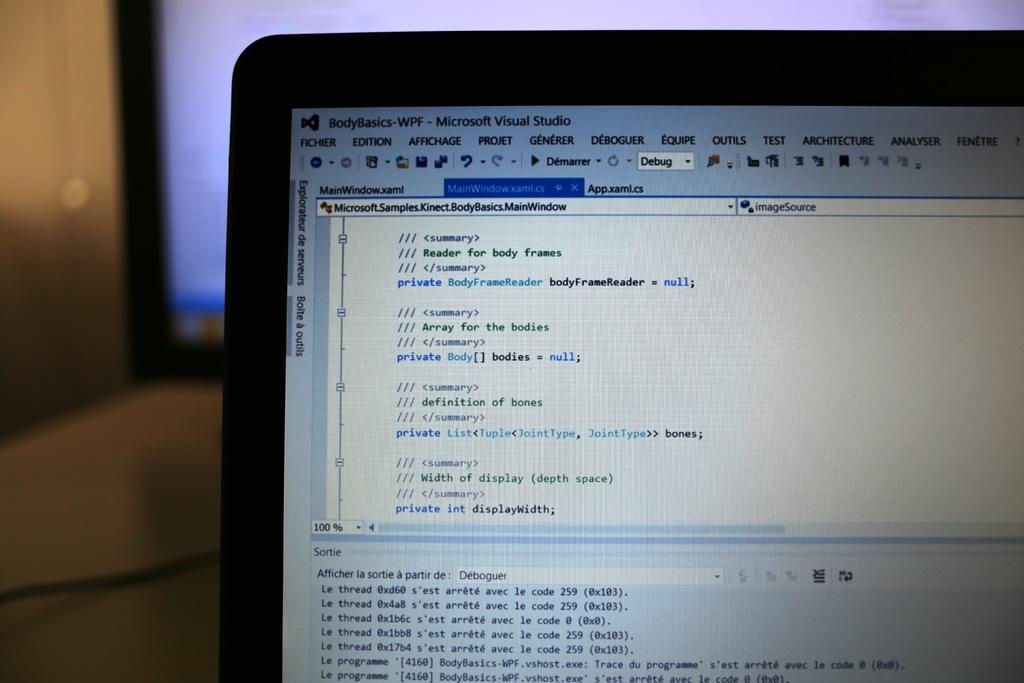Provide a one-sentence caption for the provided image. a partial laptop screen filled with Microsoft Visual Studio code. 